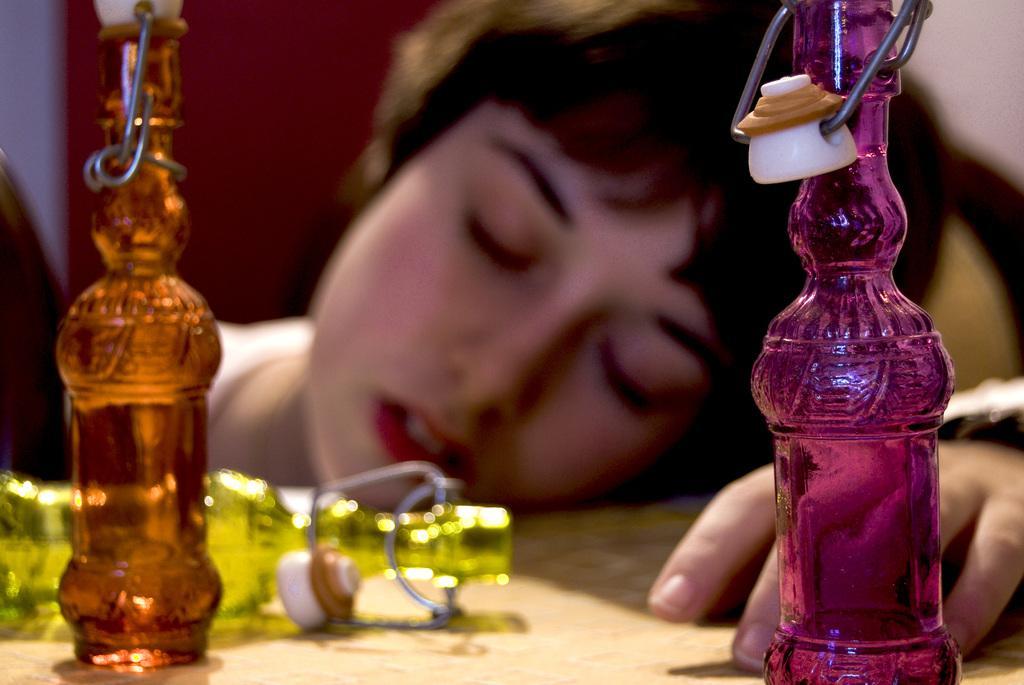In one or two sentences, can you explain what this image depicts? In this picture there is a woman lying on the table. A pink bottle, orange bottle and a yellow bottle are seen on the table. 